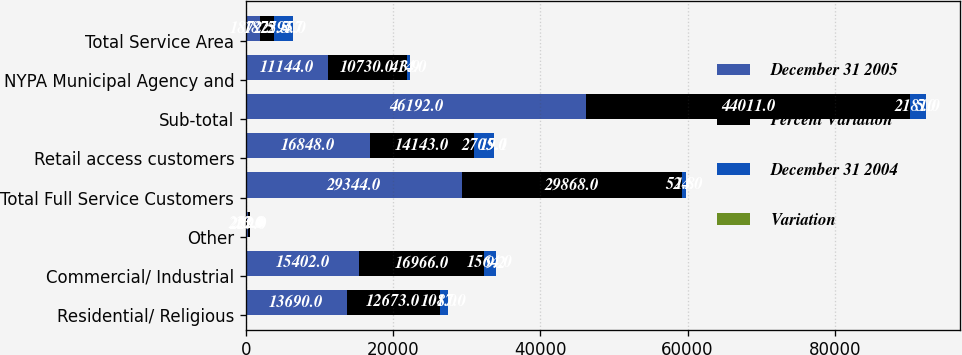Convert chart. <chart><loc_0><loc_0><loc_500><loc_500><stacked_bar_chart><ecel><fcel>Residential/ Religious<fcel>Commercial/ Industrial<fcel>Other<fcel>Total Full Service Customers<fcel>Retail access customers<fcel>Sub-total<fcel>NYPA Municipal Agency and<fcel>Total Service Area<nl><fcel>December 31 2005<fcel>13690<fcel>15402<fcel>252<fcel>29344<fcel>16848<fcel>46192<fcel>11144<fcel>1872.5<nl><fcel>Percent Variation<fcel>12673<fcel>16966<fcel>229<fcel>29868<fcel>14143<fcel>44011<fcel>10730<fcel>1872.5<nl><fcel>December 31 2004<fcel>1017<fcel>1564<fcel>23<fcel>524<fcel>2705<fcel>2181<fcel>414<fcel>2595<nl><fcel>Variation<fcel>8<fcel>9.2<fcel>10<fcel>1.8<fcel>19.1<fcel>5<fcel>3.9<fcel>4.7<nl></chart> 